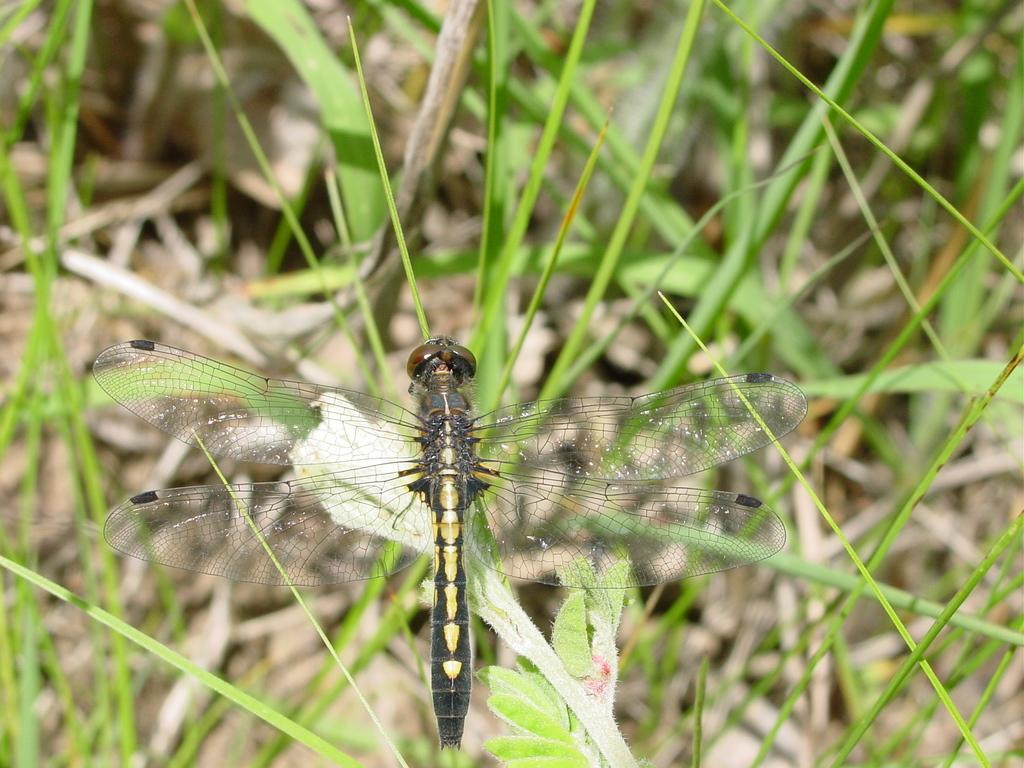What is the main subject in the foreground of the image? There is a dragonfly in the foreground of the image. Where is the dragonfly located? The dragonfly is on a leaf. What type of vegetation can be seen in the background of the image? There is grass visible in the background of the image. Can you tell me how many books are on the shelf behind the dragonfly in the image? There is no shelf or books present in the image; it features a dragonfly on a leaf with grass visible in the background. 